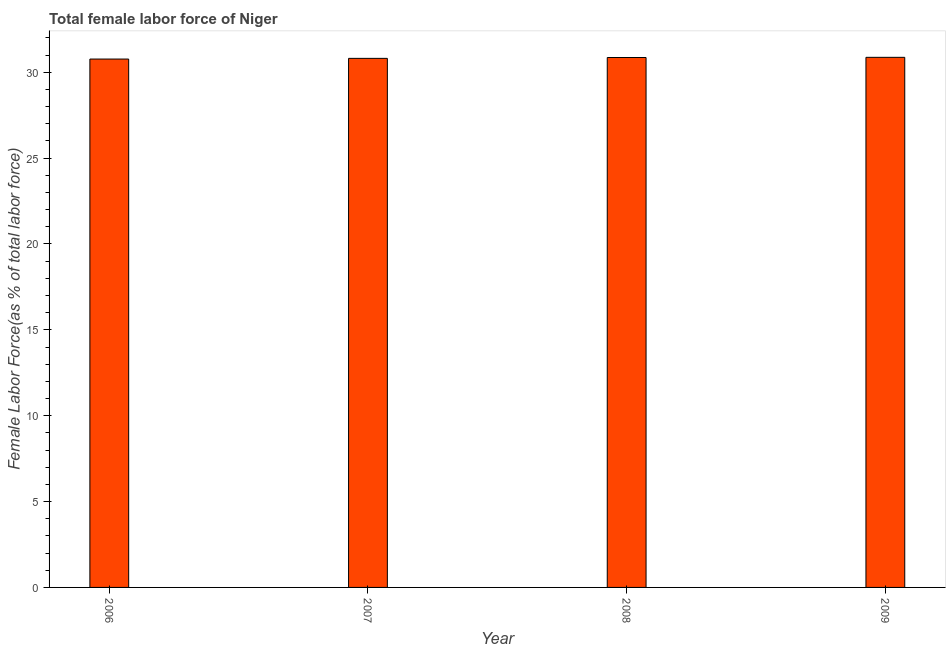Does the graph contain grids?
Offer a very short reply. No. What is the title of the graph?
Your answer should be compact. Total female labor force of Niger. What is the label or title of the Y-axis?
Offer a very short reply. Female Labor Force(as % of total labor force). What is the total female labor force in 2007?
Your answer should be very brief. 30.81. Across all years, what is the maximum total female labor force?
Make the answer very short. 30.87. Across all years, what is the minimum total female labor force?
Provide a succinct answer. 30.77. In which year was the total female labor force maximum?
Give a very brief answer. 2009. What is the sum of the total female labor force?
Offer a terse response. 123.31. What is the difference between the total female labor force in 2006 and 2009?
Make the answer very short. -0.1. What is the average total female labor force per year?
Offer a very short reply. 30.83. What is the median total female labor force?
Offer a very short reply. 30.84. In how many years, is the total female labor force greater than 1 %?
Your answer should be compact. 4. What is the ratio of the total female labor force in 2006 to that in 2009?
Offer a very short reply. 1. Is the total female labor force in 2007 less than that in 2009?
Offer a very short reply. Yes. What is the difference between the highest and the second highest total female labor force?
Make the answer very short. 0.01. Is the sum of the total female labor force in 2006 and 2008 greater than the maximum total female labor force across all years?
Ensure brevity in your answer.  Yes. What is the difference between the highest and the lowest total female labor force?
Your answer should be compact. 0.1. Are all the bars in the graph horizontal?
Make the answer very short. No. How many years are there in the graph?
Your answer should be compact. 4. What is the difference between two consecutive major ticks on the Y-axis?
Your response must be concise. 5. Are the values on the major ticks of Y-axis written in scientific E-notation?
Offer a very short reply. No. What is the Female Labor Force(as % of total labor force) of 2006?
Offer a very short reply. 30.77. What is the Female Labor Force(as % of total labor force) of 2007?
Make the answer very short. 30.81. What is the Female Labor Force(as % of total labor force) in 2008?
Your answer should be very brief. 30.86. What is the Female Labor Force(as % of total labor force) of 2009?
Your answer should be compact. 30.87. What is the difference between the Female Labor Force(as % of total labor force) in 2006 and 2007?
Your answer should be compact. -0.04. What is the difference between the Female Labor Force(as % of total labor force) in 2006 and 2008?
Make the answer very short. -0.09. What is the difference between the Female Labor Force(as % of total labor force) in 2006 and 2009?
Ensure brevity in your answer.  -0.1. What is the difference between the Female Labor Force(as % of total labor force) in 2007 and 2008?
Your answer should be compact. -0.05. What is the difference between the Female Labor Force(as % of total labor force) in 2007 and 2009?
Your answer should be very brief. -0.06. What is the difference between the Female Labor Force(as % of total labor force) in 2008 and 2009?
Provide a succinct answer. -0.01. What is the ratio of the Female Labor Force(as % of total labor force) in 2006 to that in 2007?
Your response must be concise. 1. What is the ratio of the Female Labor Force(as % of total labor force) in 2006 to that in 2009?
Ensure brevity in your answer.  1. What is the ratio of the Female Labor Force(as % of total labor force) in 2007 to that in 2009?
Provide a short and direct response. 1. 